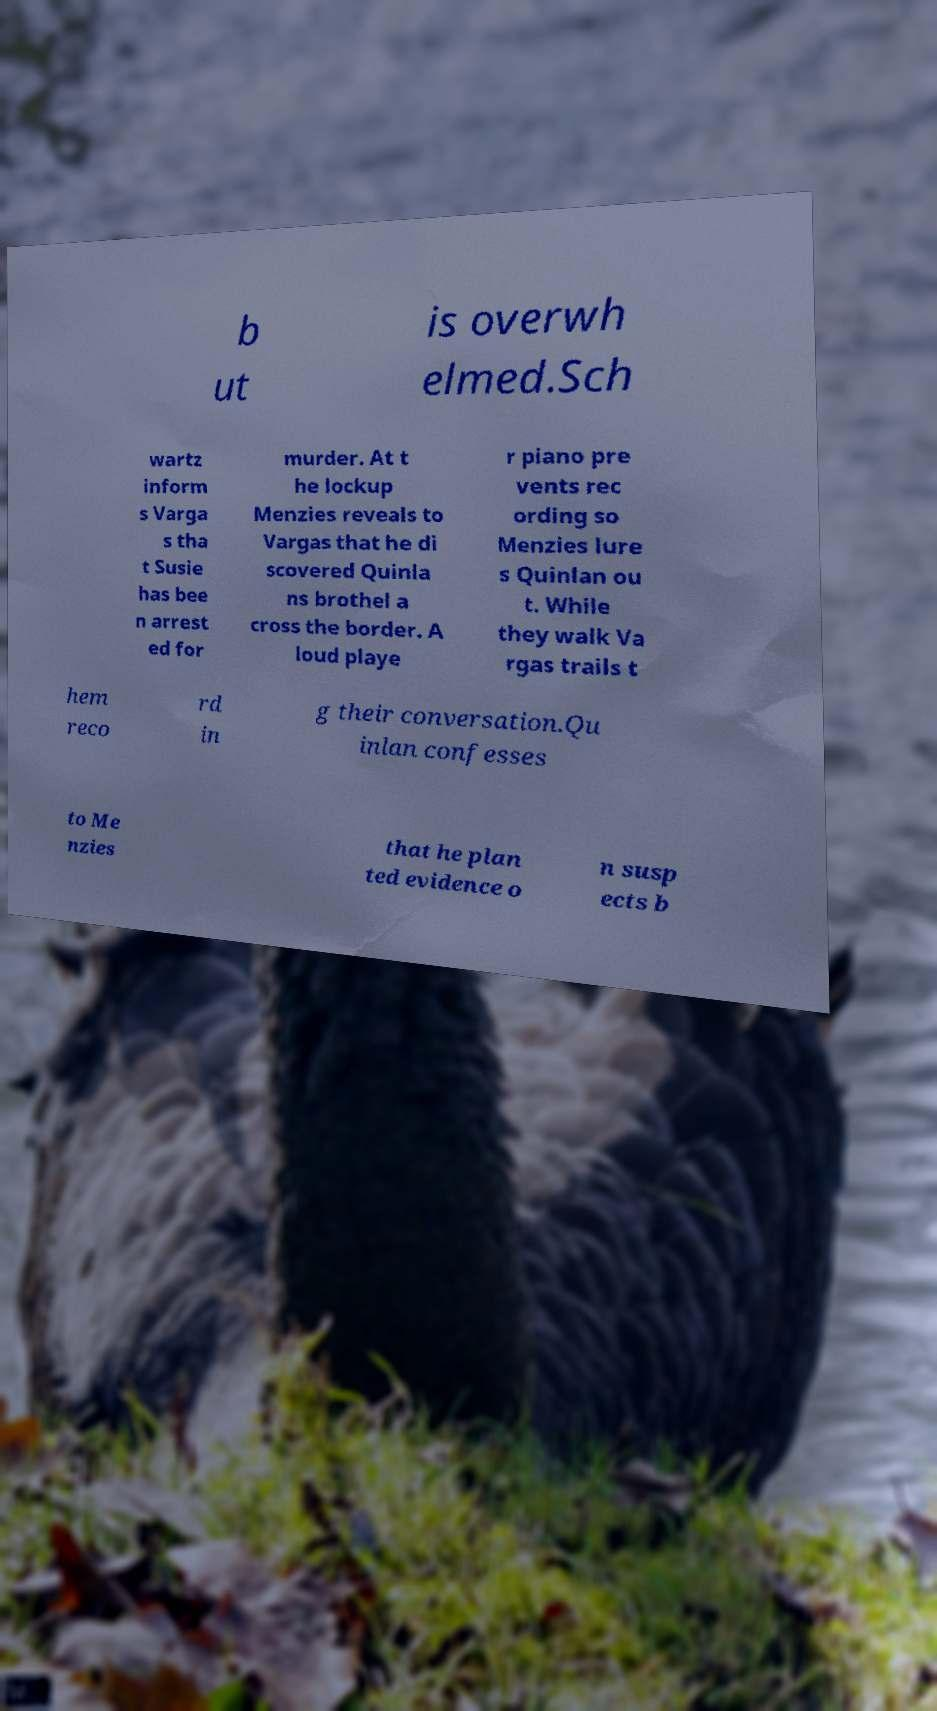I need the written content from this picture converted into text. Can you do that? b ut is overwh elmed.Sch wartz inform s Varga s tha t Susie has bee n arrest ed for murder. At t he lockup Menzies reveals to Vargas that he di scovered Quinla ns brothel a cross the border. A loud playe r piano pre vents rec ording so Menzies lure s Quinlan ou t. While they walk Va rgas trails t hem reco rd in g their conversation.Qu inlan confesses to Me nzies that he plan ted evidence o n susp ects b 